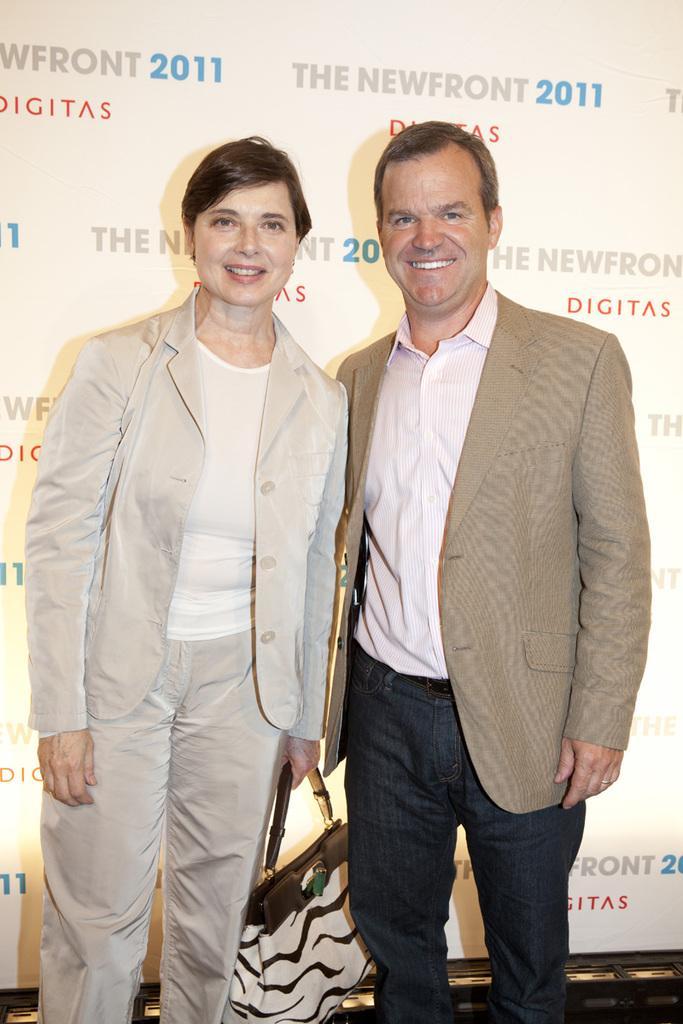Can you describe this image briefly? In the image we can see two persons were standing. On the left there is a lady she is smiling and on the right the man he is also smiling. And the lady she is holding one hand bag. 